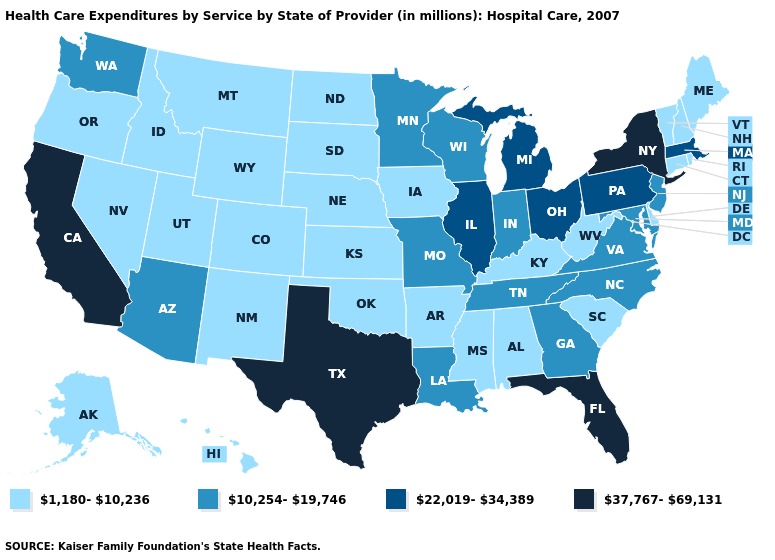What is the value of Nebraska?
Give a very brief answer. 1,180-10,236. Which states hav the highest value in the MidWest?
Keep it brief. Illinois, Michigan, Ohio. Name the states that have a value in the range 22,019-34,389?
Be succinct. Illinois, Massachusetts, Michigan, Ohio, Pennsylvania. Which states have the lowest value in the MidWest?
Give a very brief answer. Iowa, Kansas, Nebraska, North Dakota, South Dakota. Does the first symbol in the legend represent the smallest category?
Be succinct. Yes. What is the value of Nebraska?
Concise answer only. 1,180-10,236. Does Maine have the same value as California?
Give a very brief answer. No. Does the first symbol in the legend represent the smallest category?
Write a very short answer. Yes. Does Pennsylvania have a higher value than Kentucky?
Write a very short answer. Yes. What is the value of Kansas?
Be succinct. 1,180-10,236. Does Alabama have the same value as Montana?
Write a very short answer. Yes. Which states have the highest value in the USA?
Concise answer only. California, Florida, New York, Texas. Name the states that have a value in the range 1,180-10,236?
Give a very brief answer. Alabama, Alaska, Arkansas, Colorado, Connecticut, Delaware, Hawaii, Idaho, Iowa, Kansas, Kentucky, Maine, Mississippi, Montana, Nebraska, Nevada, New Hampshire, New Mexico, North Dakota, Oklahoma, Oregon, Rhode Island, South Carolina, South Dakota, Utah, Vermont, West Virginia, Wyoming. What is the value of North Dakota?
Answer briefly. 1,180-10,236. Name the states that have a value in the range 1,180-10,236?
Answer briefly. Alabama, Alaska, Arkansas, Colorado, Connecticut, Delaware, Hawaii, Idaho, Iowa, Kansas, Kentucky, Maine, Mississippi, Montana, Nebraska, Nevada, New Hampshire, New Mexico, North Dakota, Oklahoma, Oregon, Rhode Island, South Carolina, South Dakota, Utah, Vermont, West Virginia, Wyoming. 